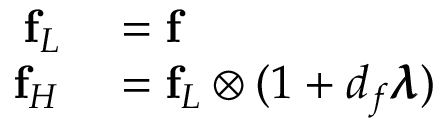<formula> <loc_0><loc_0><loc_500><loc_500>\begin{array} { r l } { f _ { L } } & = f } \\ { f _ { H } } & = f _ { L } \otimes ( 1 + d _ { f } \pm b { \lambda } ) } \end{array}</formula> 